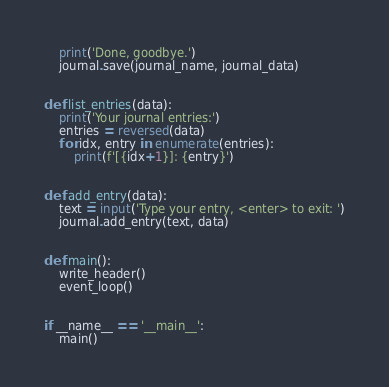Convert code to text. <code><loc_0><loc_0><loc_500><loc_500><_Python_>
    print('Done, goodbye.')
    journal.save(journal_name, journal_data)


def list_entries(data):
    print('Your journal entries:')
    entries = reversed(data)
    for idx, entry in enumerate(entries):
        print(f'[{idx+1}]: {entry}')


def add_entry(data):
    text = input('Type your entry, <enter> to exit: ')
    journal.add_entry(text, data)


def main():
    write_header()
    event_loop()


if __name__ == '__main__':
    main()
</code> 